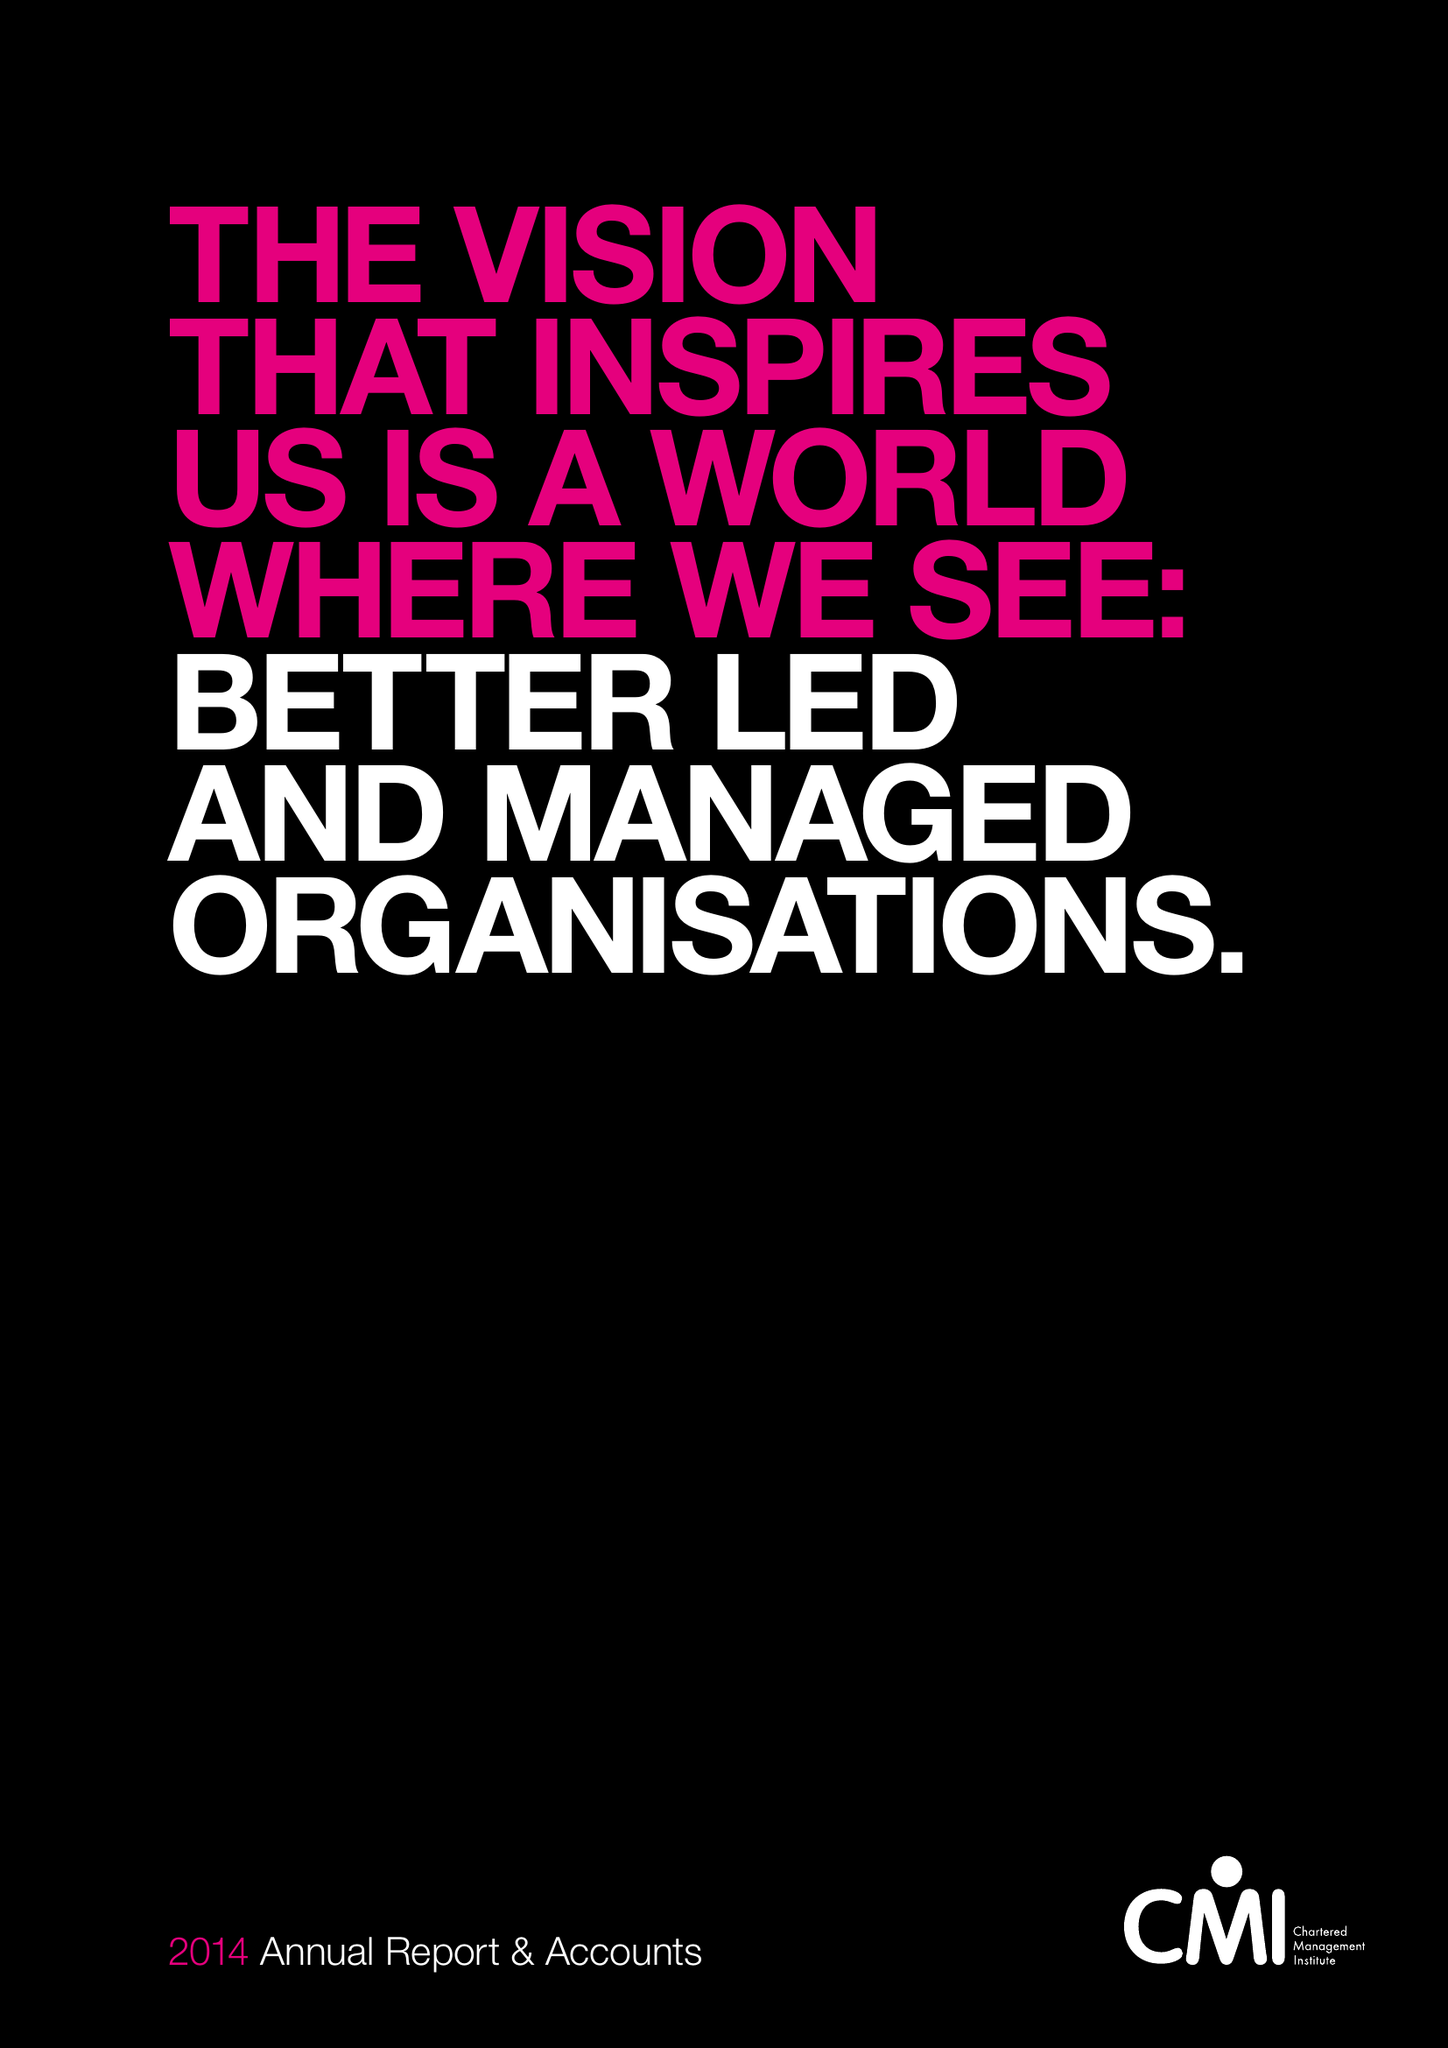What is the value for the address__post_town?
Answer the question using a single word or phrase. CORBY 